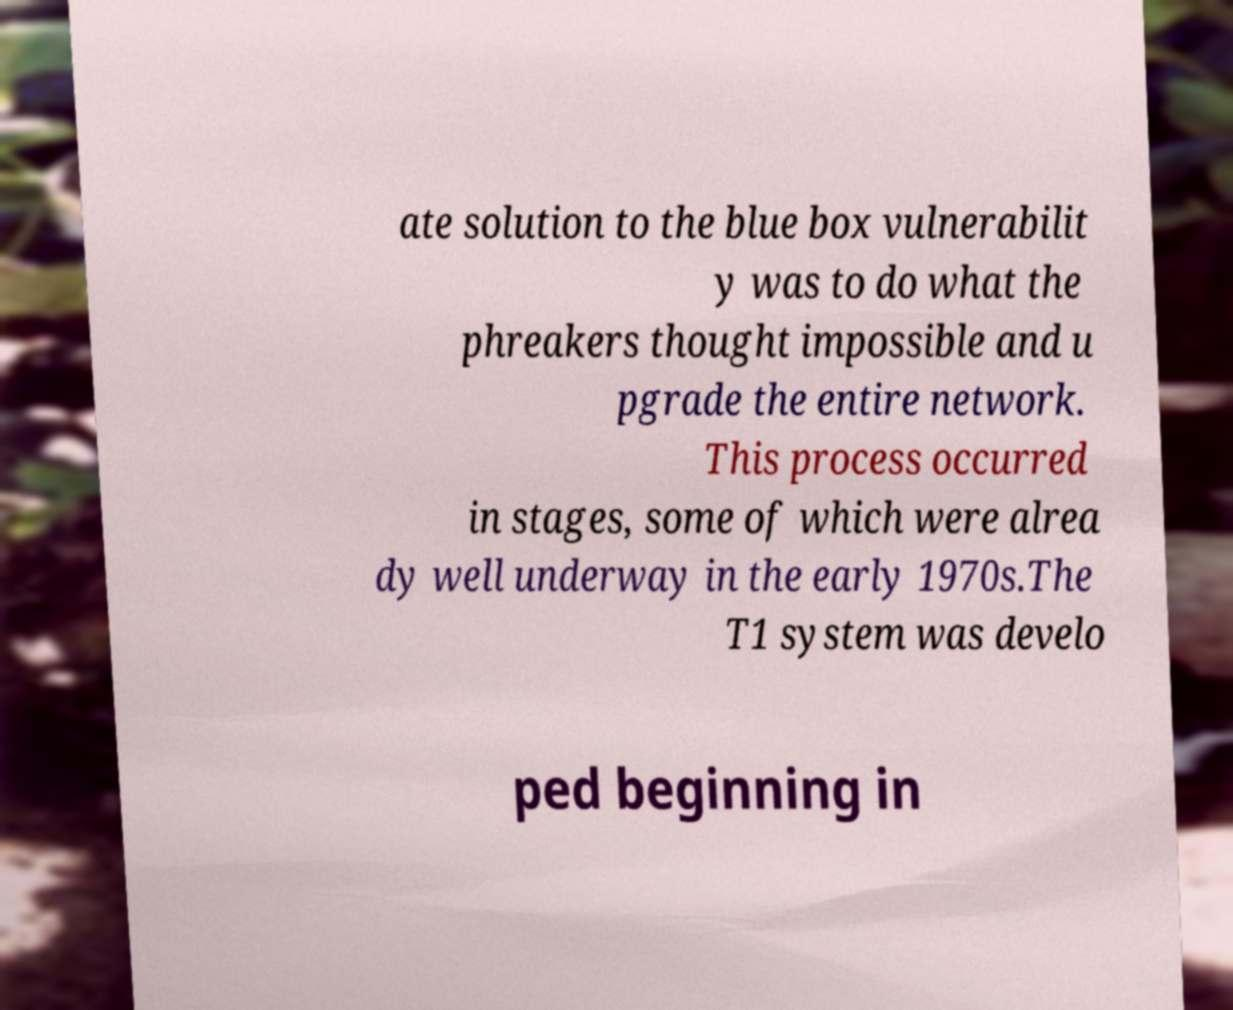There's text embedded in this image that I need extracted. Can you transcribe it verbatim? ate solution to the blue box vulnerabilit y was to do what the phreakers thought impossible and u pgrade the entire network. This process occurred in stages, some of which were alrea dy well underway in the early 1970s.The T1 system was develo ped beginning in 